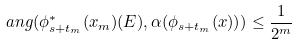Convert formula to latex. <formula><loc_0><loc_0><loc_500><loc_500>a n g ( \phi _ { s + t _ { m } } ^ { \ast } ( x _ { m } ) ( E ) , \alpha ( \phi _ { s + t _ { m } } ( x ) ) ) \leq \frac { 1 } { 2 ^ { m } }</formula> 